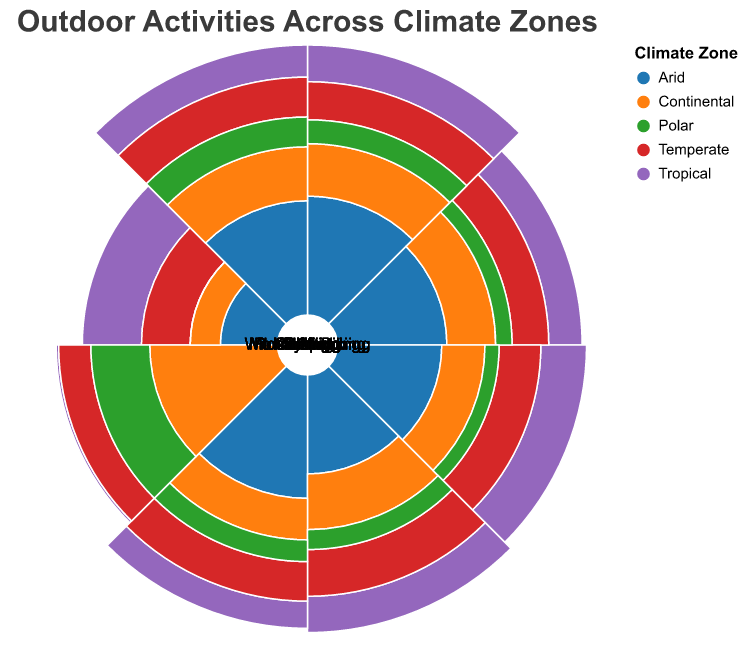What is the most popular outdoor activity in the Tropical climate zone? To find the most popular activity in the Tropical climate zone, look for the highest value among the activities corresponding to the Tropical zone. Kayaking has a value of 95, which is the highest.
Answer: Kayaking Which climate zone has the highest value for skiing? Compare the values of skiing across all climate zones. The Polar zone has the highest value for skiing at 85.
Answer: Polar What is the average popularity value for hiking across all climate zones? Sum the values of hiking for all climate zones and divide by the number of zones. The values are 85 (Tropical) + 65 (Arid) + 75 (Temperate) + 70 (Continental) + 40 (Polar) = 335. Dividing 335 by 5 gives 67.
Answer: 67 Between Rock Climbing and Surfing, which activity is more popular in the Arid climate zone? Compare the values for Rock Climbing (70) and Surfing (15) in the Arid zone. Rock Climbing has a higher value.
Answer: Rock Climbing Which climate zone has the least popularity for kayaking? Compare the kayaking values across all climate zones. The Polar zone has the least popularity for kayaking with a value of 20.
Answer: Polar In the Temperate zone, is wildlife watching more popular than camping? Compare the values for wildlife watching (85) and camping (80) in the Temperate zone. Wildlife watching has a higher value.
Answer: Yes How does the value for surfing in the Tropical zone compare to the value for the same activity in the Temperate zone? Compare the values for surfing in the Tropical (90) and Temperate (50) zones. Surfing in the Tropical zone has a higher value.
Answer: Tropical is higher Which activities have a value of 0 in any climate zone? Identify activities with a value of 0 in any climate zone. Skiing in the Arid zone and Surfing in the Polar zone have values of 0.
Answer: Skiing and Surfing 